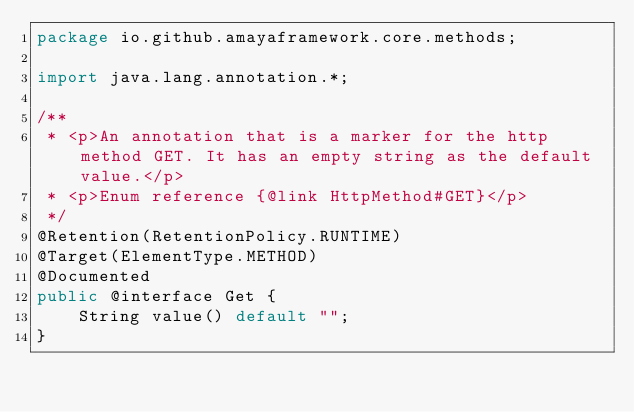<code> <loc_0><loc_0><loc_500><loc_500><_Java_>package io.github.amayaframework.core.methods;

import java.lang.annotation.*;

/**
 * <p>An annotation that is a marker for the http method GET. It has an empty string as the default value.</p>
 * <p>Enum reference {@link HttpMethod#GET}</p>
 */
@Retention(RetentionPolicy.RUNTIME)
@Target(ElementType.METHOD)
@Documented
public @interface Get {
    String value() default "";
}
</code> 